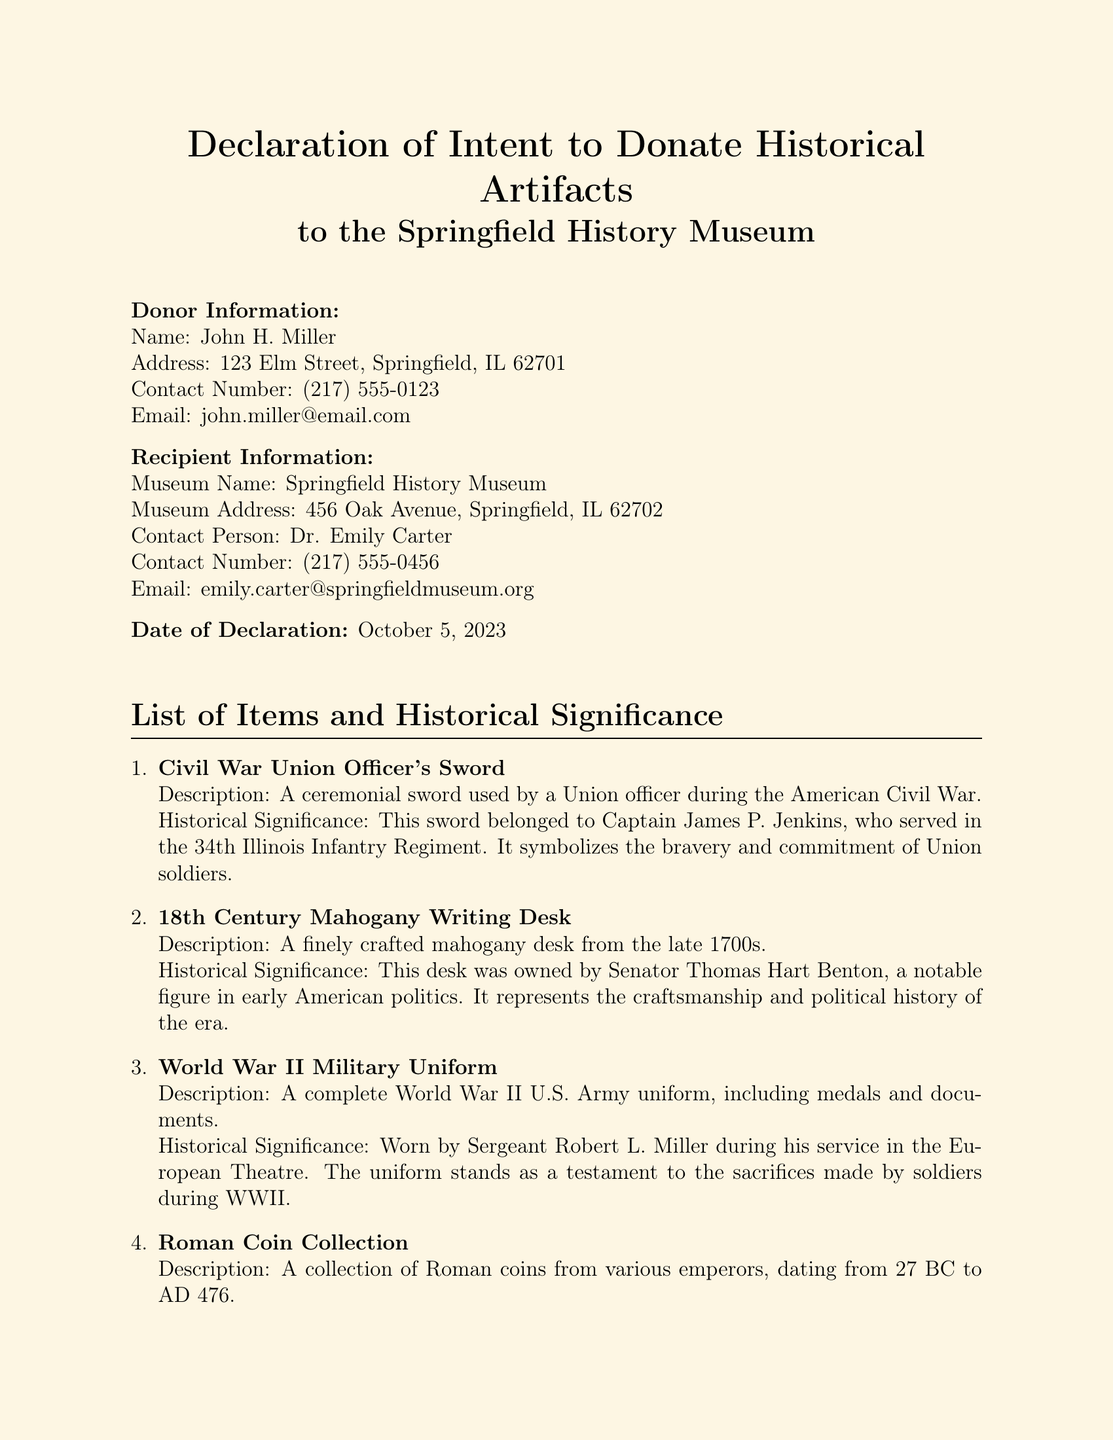What is the name of the donor? The donor's name is stated clearly in the document.
Answer: John H. Miller What is the address of the museum? The museum's address is provided under the recipient information.
Answer: 456 Oak Avenue, Springfield, IL 62702 On what date was the declaration made? The date of the declaration is mentioned in the document.
Answer: October 5, 2023 What item belonged to Captain James P. Jenkins? This information is found under the list of items and their historical significance.
Answer: Civil War Union Officer's Sword What does the 18th Century Mahogany Writing Desk represent? This is explained in the historical significance section for the desk.
Answer: Craftsmanship and political history of the era How many artifacts are listed in the declaration? This can be calculated based on the items listed in the document.
Answer: Four Who is the contact person at the museum? The document specifies the contact person for the museum.
Answer: Dr. Emily Carter What military event is the uniform associated with? The historical significance details the context of the uniform.
Answer: World War II What type of collection is related to the Roman Empire? The document describes the specific type of collection in the list of items.
Answer: Roman Coin Collection 